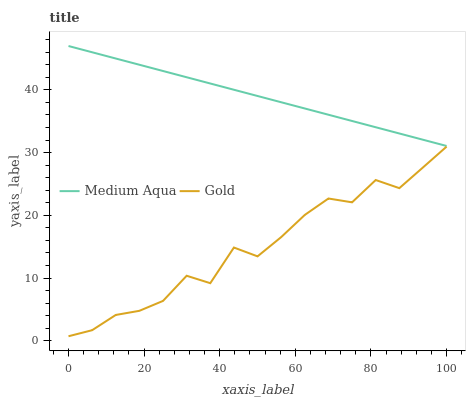Does Gold have the minimum area under the curve?
Answer yes or no. Yes. Does Medium Aqua have the maximum area under the curve?
Answer yes or no. Yes. Does Gold have the maximum area under the curve?
Answer yes or no. No. Is Medium Aqua the smoothest?
Answer yes or no. Yes. Is Gold the roughest?
Answer yes or no. Yes. Is Gold the smoothest?
Answer yes or no. No. Does Gold have the lowest value?
Answer yes or no. Yes. Does Medium Aqua have the highest value?
Answer yes or no. Yes. Does Gold have the highest value?
Answer yes or no. No. Is Gold less than Medium Aqua?
Answer yes or no. Yes. Is Medium Aqua greater than Gold?
Answer yes or no. Yes. Does Gold intersect Medium Aqua?
Answer yes or no. No. 